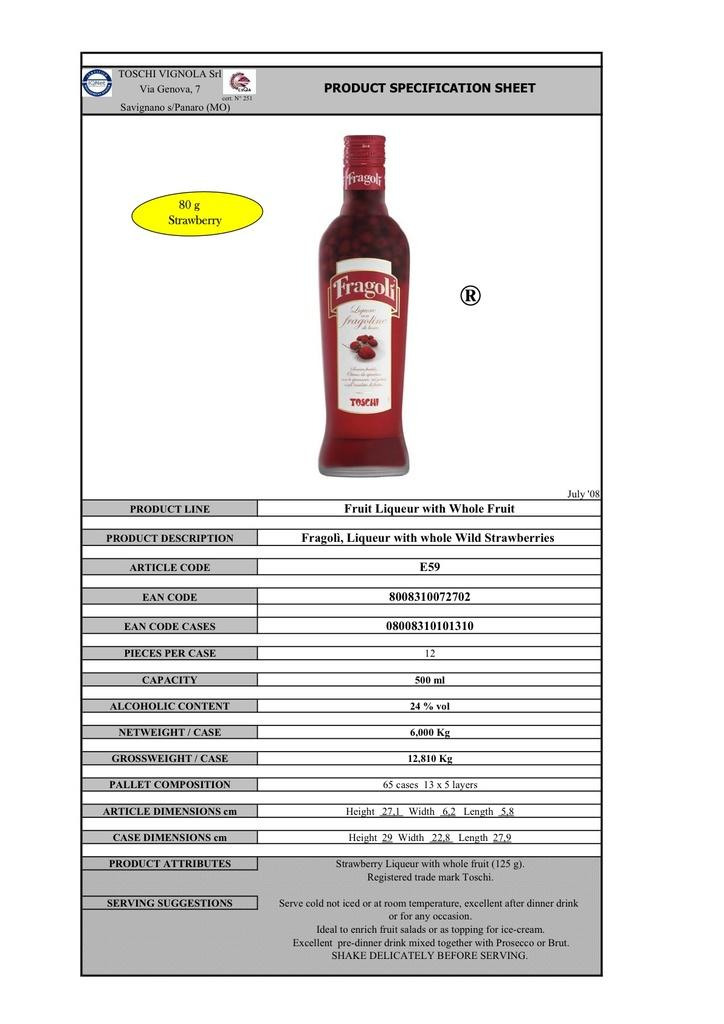Provide a one-sentence caption for the provided image. Product Specification sheet for  Fragoli Liqueur with whole fruit. 